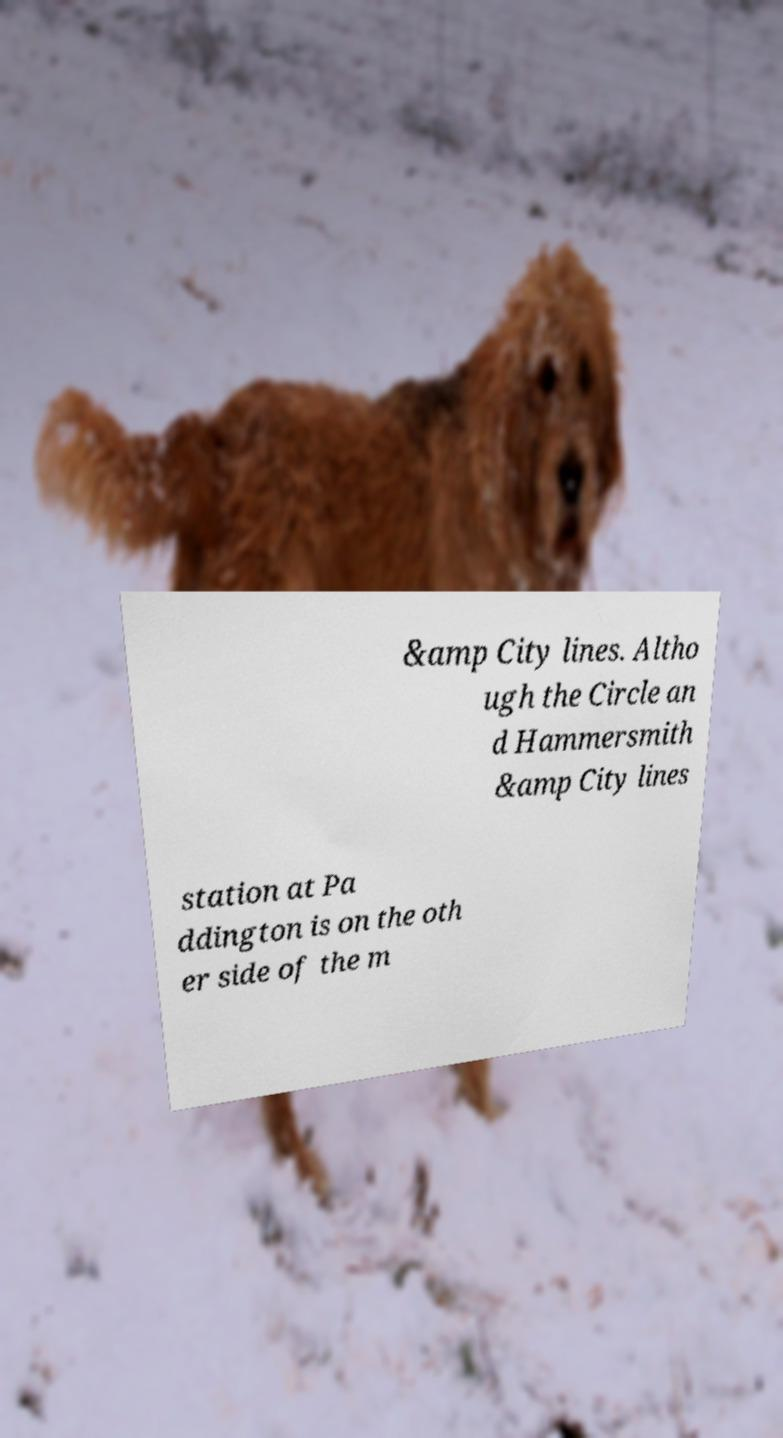Could you extract and type out the text from this image? &amp City lines. Altho ugh the Circle an d Hammersmith &amp City lines station at Pa ddington is on the oth er side of the m 